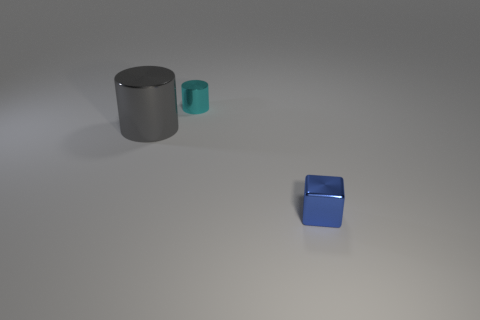Is the number of small blue metal objects on the right side of the blue metallic block less than the number of large shiny cylinders?
Your answer should be compact. Yes. What is the shape of the small object that is behind the metal object on the left side of the metal object behind the large metallic cylinder?
Your answer should be compact. Cylinder. There is a shiny cylinder to the right of the gray thing; what size is it?
Your response must be concise. Small. There is another metal object that is the same size as the cyan object; what shape is it?
Make the answer very short. Cube. What number of things are either big red metal balls or metal things on the left side of the small metallic block?
Provide a succinct answer. 2. There is a tiny cyan cylinder on the right side of the shiny object that is on the left side of the cyan metallic thing; how many cyan things are left of it?
Give a very brief answer. 0. The big object that is made of the same material as the blue block is what color?
Offer a terse response. Gray. Do the metal cylinder that is behind the gray metallic thing and the block have the same size?
Provide a short and direct response. Yes. How many things are large gray cylinders or cyan objects?
Ensure brevity in your answer.  2. What is the material of the small thing behind the tiny thing that is right of the small object that is to the left of the small blue object?
Your answer should be very brief. Metal. 